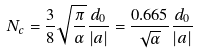Convert formula to latex. <formula><loc_0><loc_0><loc_500><loc_500>N _ { c } = \frac { 3 } { 8 } \sqrt { \frac { \pi } { \alpha } } \frac { d _ { 0 } } { | a | } = \frac { 0 . 6 6 5 } { \sqrt { \alpha } } \frac { d _ { 0 } } { | a | }</formula> 